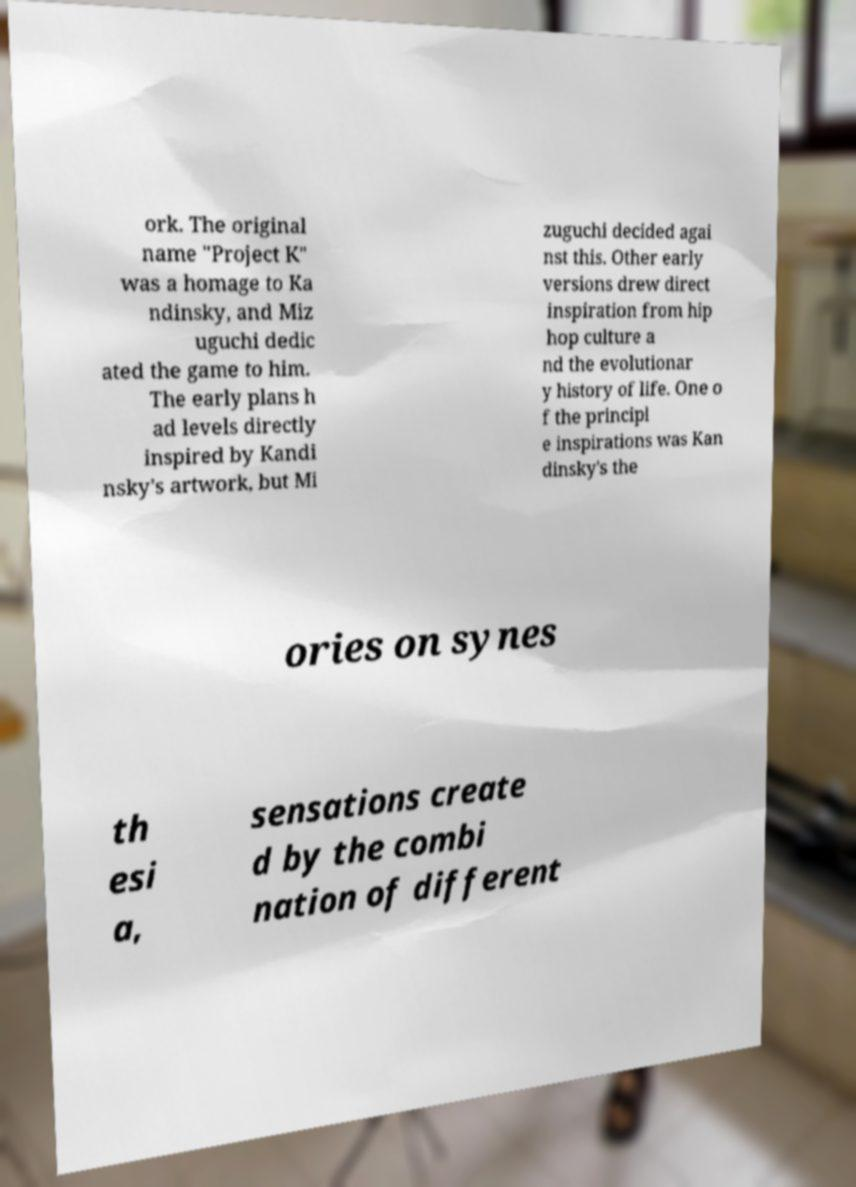Please read and relay the text visible in this image. What does it say? ork. The original name "Project K" was a homage to Ka ndinsky, and Miz uguchi dedic ated the game to him. The early plans h ad levels directly inspired by Kandi nsky's artwork, but Mi zuguchi decided agai nst this. Other early versions drew direct inspiration from hip hop culture a nd the evolutionar y history of life. One o f the principl e inspirations was Kan dinsky's the ories on synes th esi a, sensations create d by the combi nation of different 